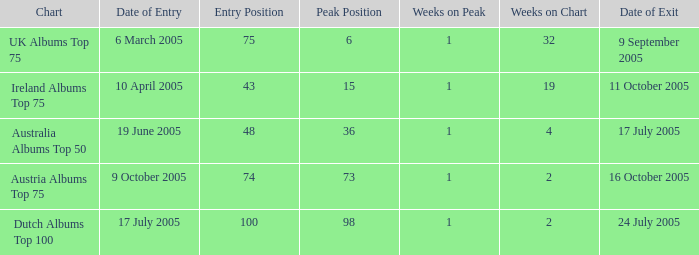What is the departure date for the dutch albums top 100 chart? 24 July 2005. 